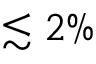Convert formula to latex. <formula><loc_0><loc_0><loc_500><loc_500>\lesssim 2 \%</formula> 